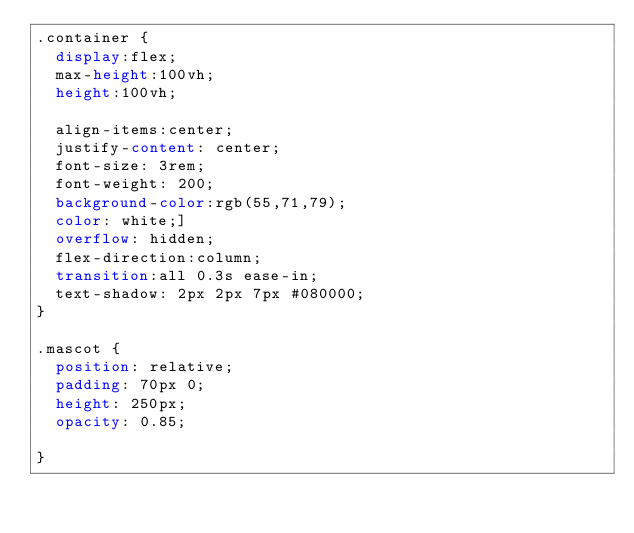Convert code to text. <code><loc_0><loc_0><loc_500><loc_500><_CSS_>.container {
  display:flex;
  max-height:100vh;
  height:100vh;

  align-items:center;
  justify-content: center;
  font-size: 3rem;
  font-weight: 200;
  background-color:rgb(55,71,79);
  color: white;]
  overflow: hidden;
  flex-direction:column;
  transition:all 0.3s ease-in;
  text-shadow: 2px 2px 7px #080000;
}

.mascot {
  position: relative;
  padding: 70px 0;
  height: 250px;
  opacity: 0.85;

}</code> 